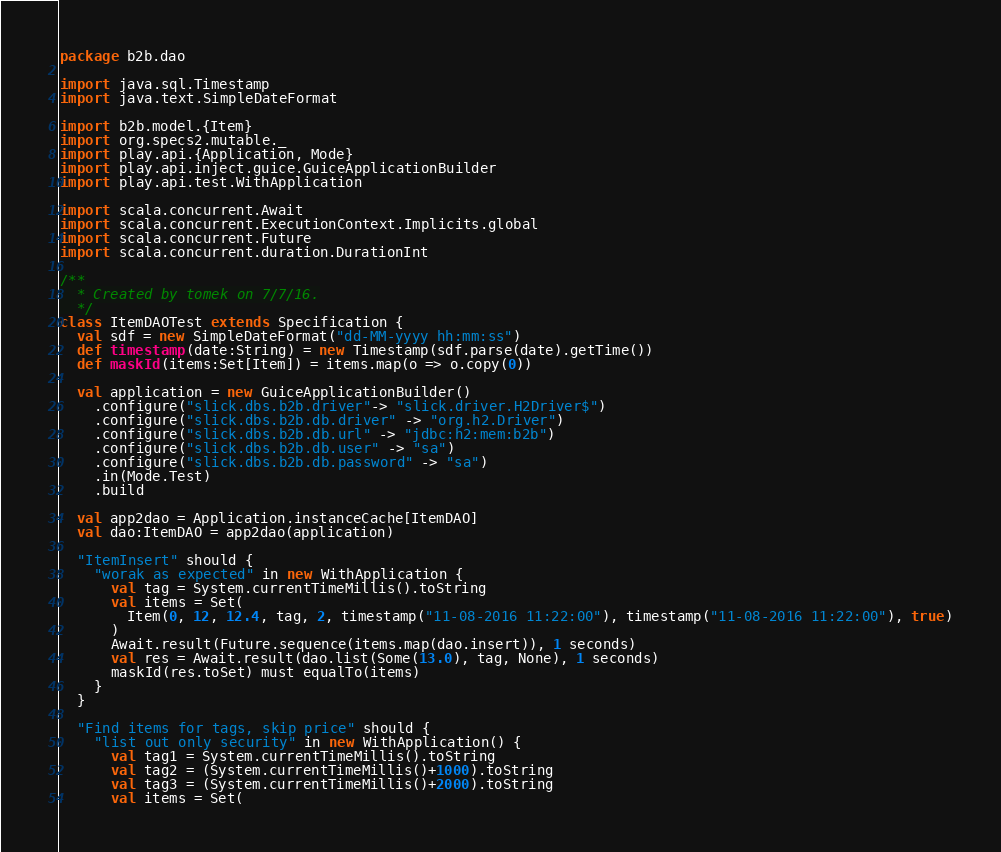<code> <loc_0><loc_0><loc_500><loc_500><_Scala_>package b2b.dao

import java.sql.Timestamp
import java.text.SimpleDateFormat

import b2b.model.{Item}
import org.specs2.mutable._
import play.api.{Application, Mode}
import play.api.inject.guice.GuiceApplicationBuilder
import play.api.test.WithApplication

import scala.concurrent.Await
import scala.concurrent.ExecutionContext.Implicits.global
import scala.concurrent.Future
import scala.concurrent.duration.DurationInt

/**
  * Created by tomek on 7/7/16.
  */
class ItemDAOTest extends Specification {
  val sdf = new SimpleDateFormat("dd-MM-yyyy hh:mm:ss")
  def timestamp(date:String) = new Timestamp(sdf.parse(date).getTime())
  def maskId(items:Set[Item]) = items.map(o => o.copy(0))

  val application = new GuiceApplicationBuilder()
    .configure("slick.dbs.b2b.driver"-> "slick.driver.H2Driver$")
    .configure("slick.dbs.b2b.db.driver" -> "org.h2.Driver")
    .configure("slick.dbs.b2b.db.url" -> "jdbc:h2:mem:b2b")
    .configure("slick.dbs.b2b.db.user" -> "sa")
    .configure("slick.dbs.b2b.db.password" -> "sa")
    .in(Mode.Test)
    .build

  val app2dao = Application.instanceCache[ItemDAO]
  val dao:ItemDAO = app2dao(application)

  "ItemInsert" should {
    "worak as expected" in new WithApplication {
      val tag = System.currentTimeMillis().toString
      val items = Set(
        Item(0, 12, 12.4, tag, 2, timestamp("11-08-2016 11:22:00"), timestamp("11-08-2016 11:22:00"), true)
      )
      Await.result(Future.sequence(items.map(dao.insert)), 1 seconds)
      val res = Await.result(dao.list(Some(13.0), tag, None), 1 seconds)
      maskId(res.toSet) must equalTo(items)
    }
  }

  "Find items for tags, skip price" should {
    "list out only security" in new WithApplication() {
      val tag1 = System.currentTimeMillis().toString
      val tag2 = (System.currentTimeMillis()+1000).toString
      val tag3 = (System.currentTimeMillis()+2000).toString
      val items = Set(</code> 